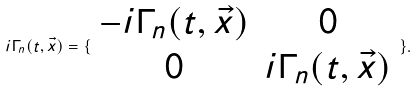<formula> <loc_0><loc_0><loc_500><loc_500>i \Gamma _ { n } ( t , \vec { x } ) = \{ \begin{array} { c c } - i \Gamma _ { n } ( t , \vec { x } ) & 0 \\ 0 & i \Gamma _ { n } ( t , \vec { x } ) \end{array} \} .</formula> 